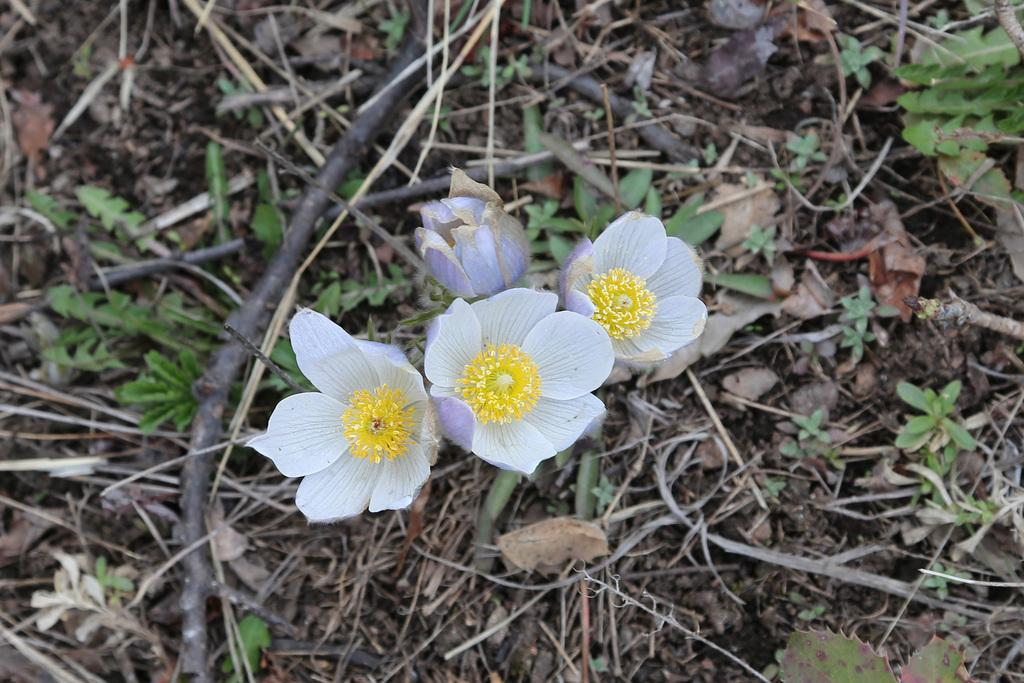What is the main subject of the image? There is a group of flowers in the image. What can be seen in the background of the image? There are sticks, plants, and dried grass present in the background of the image. What type of chalk is being used to draw on the flowers in the image? There is no chalk or drawing present in the image; it features a group of flowers and the background elements mentioned earlier. 